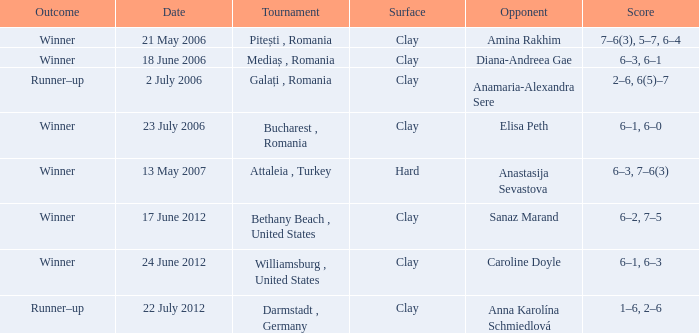What was the score in the match against Sanaz Marand? 6–2, 7–5. Parse the full table. {'header': ['Outcome', 'Date', 'Tournament', 'Surface', 'Opponent', 'Score'], 'rows': [['Winner', '21 May 2006', 'Pitești , Romania', 'Clay', 'Amina Rakhim', '7–6(3), 5–7, 6–4'], ['Winner', '18 June 2006', 'Mediaș , Romania', 'Clay', 'Diana-Andreea Gae', '6–3, 6–1'], ['Runner–up', '2 July 2006', 'Galați , Romania', 'Clay', 'Anamaria-Alexandra Sere', '2–6, 6(5)–7'], ['Winner', '23 July 2006', 'Bucharest , Romania', 'Clay', 'Elisa Peth', '6–1, 6–0'], ['Winner', '13 May 2007', 'Attaleia , Turkey', 'Hard', 'Anastasija Sevastova', '6–3, 7–6(3)'], ['Winner', '17 June 2012', 'Bethany Beach , United States', 'Clay', 'Sanaz Marand', '6–2, 7–5'], ['Winner', '24 June 2012', 'Williamsburg , United States', 'Clay', 'Caroline Doyle', '6–1, 6–3'], ['Runner–up', '22 July 2012', 'Darmstadt , Germany', 'Clay', 'Anna Karolína Schmiedlová', '1–6, 2–6']]} 